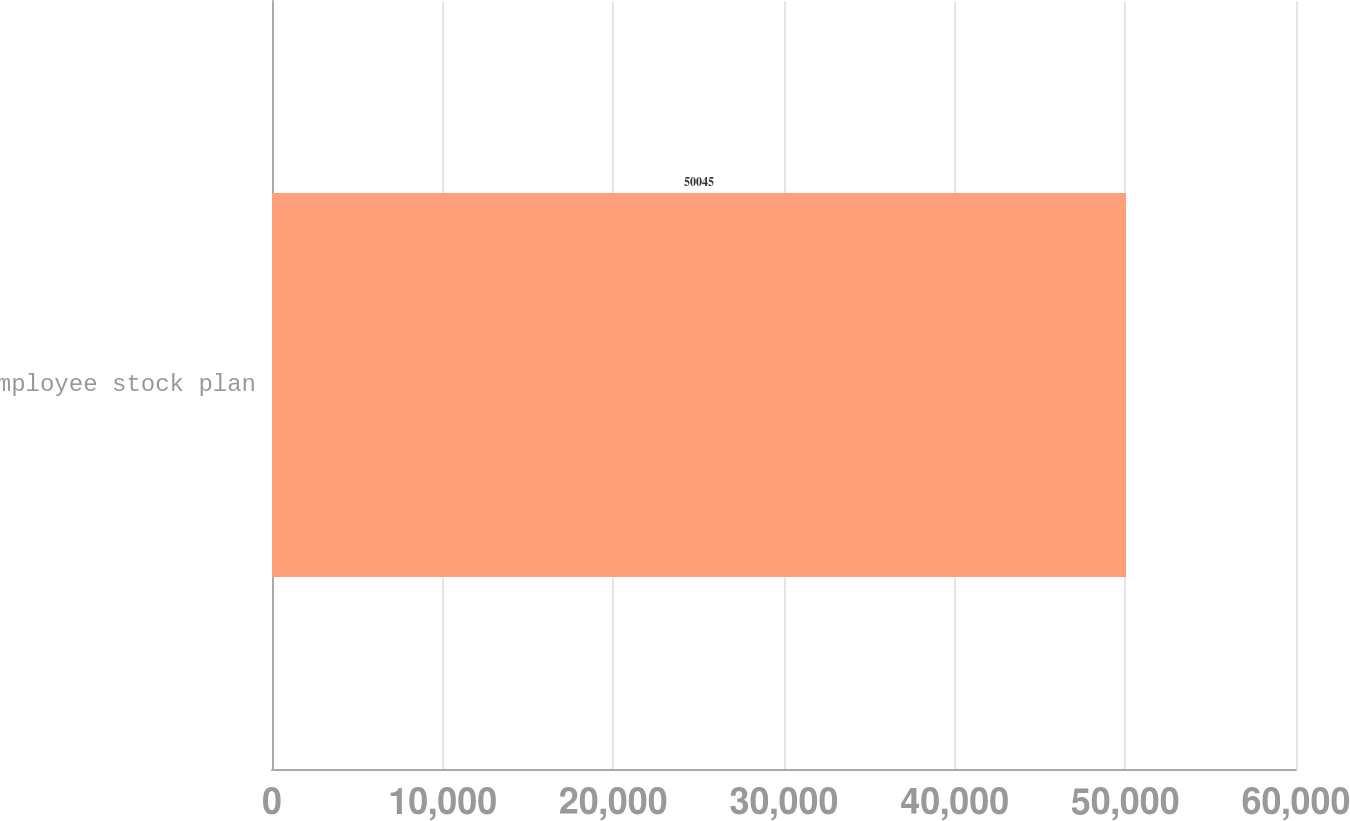<chart> <loc_0><loc_0><loc_500><loc_500><bar_chart><fcel>Employee stock plan<nl><fcel>50045<nl></chart> 